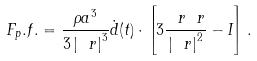Convert formula to latex. <formula><loc_0><loc_0><loc_500><loc_500>\ F _ { p } . f . = \frac { \rho a ^ { 3 } } { 3 \left | \ r \right | ^ { 3 } } \dot { d } ( t ) \cdot \left [ 3 \frac { \ r \ r } { \left | \ r \right | ^ { 2 } } - I \right ] .</formula> 